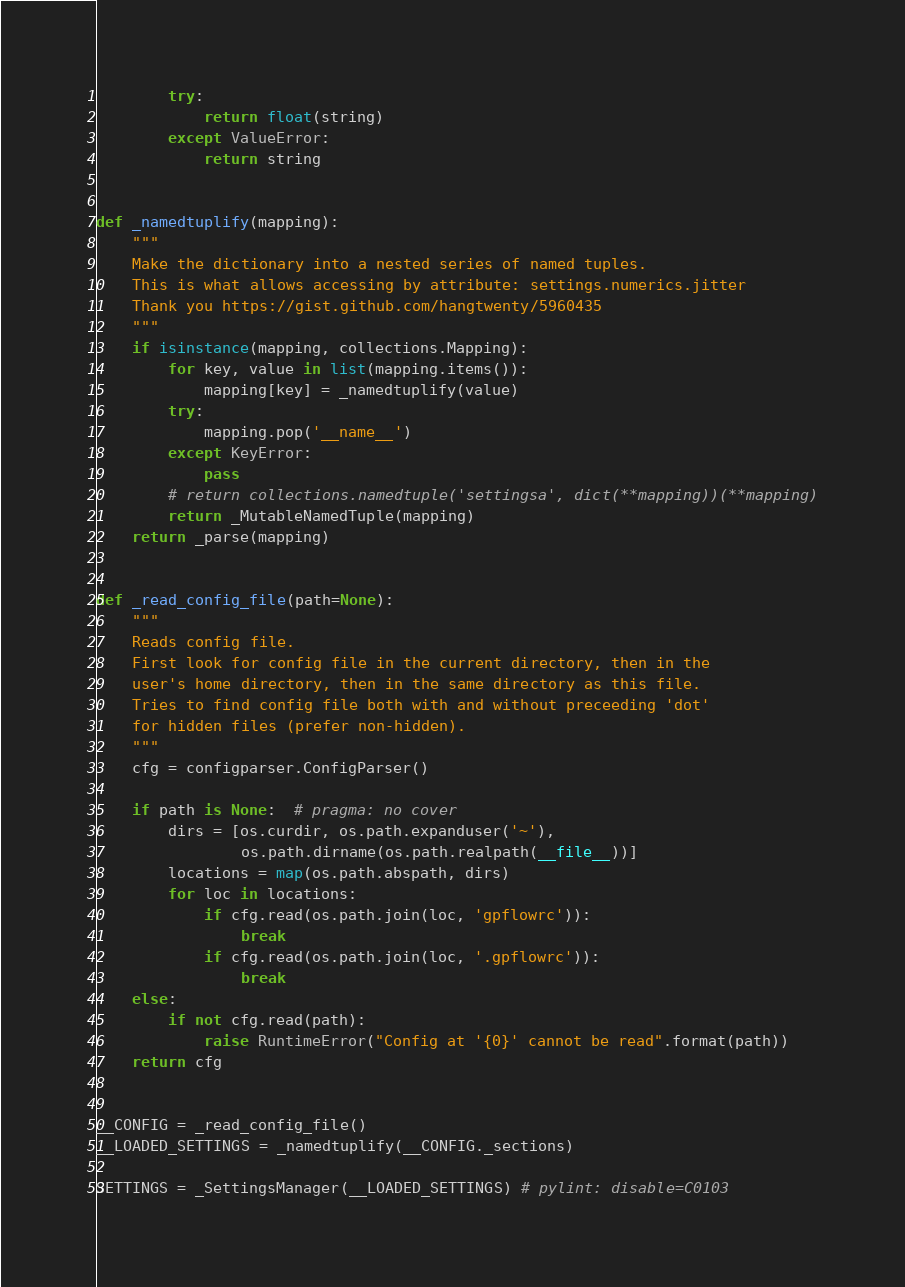Convert code to text. <code><loc_0><loc_0><loc_500><loc_500><_Python_>        try:
            return float(string)
        except ValueError:
            return string


def _namedtuplify(mapping):
    """
    Make the dictionary into a nested series of named tuples.
    This is what allows accessing by attribute: settings.numerics.jitter
    Thank you https://gist.github.com/hangtwenty/5960435
    """
    if isinstance(mapping, collections.Mapping):
        for key, value in list(mapping.items()):
            mapping[key] = _namedtuplify(value)
        try:
            mapping.pop('__name__')
        except KeyError:
            pass
        # return collections.namedtuple('settingsa', dict(**mapping))(**mapping)
        return _MutableNamedTuple(mapping)
    return _parse(mapping)


def _read_config_file(path=None):
    """
    Reads config file.
    First look for config file in the current directory, then in the
    user's home directory, then in the same directory as this file.
    Tries to find config file both with and without preceeding 'dot'
    for hidden files (prefer non-hidden).
    """
    cfg = configparser.ConfigParser()

    if path is None:  # pragma: no cover
        dirs = [os.curdir, os.path.expanduser('~'),
                os.path.dirname(os.path.realpath(__file__))]
        locations = map(os.path.abspath, dirs)
        for loc in locations:
            if cfg.read(os.path.join(loc, 'gpflowrc')):
                break
            if cfg.read(os.path.join(loc, '.gpflowrc')):
                break
    else:
        if not cfg.read(path):
            raise RuntimeError("Config at '{0}' cannot be read".format(path))
    return cfg


__CONFIG = _read_config_file()
__LOADED_SETTINGS = _namedtuplify(__CONFIG._sections)

SETTINGS = _SettingsManager(__LOADED_SETTINGS) # pylint: disable=C0103
</code> 